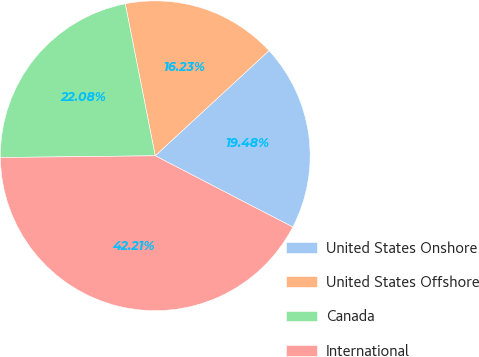<chart> <loc_0><loc_0><loc_500><loc_500><pie_chart><fcel>United States Onshore<fcel>United States Offshore<fcel>Canada<fcel>International<nl><fcel>19.48%<fcel>16.23%<fcel>22.08%<fcel>42.21%<nl></chart> 